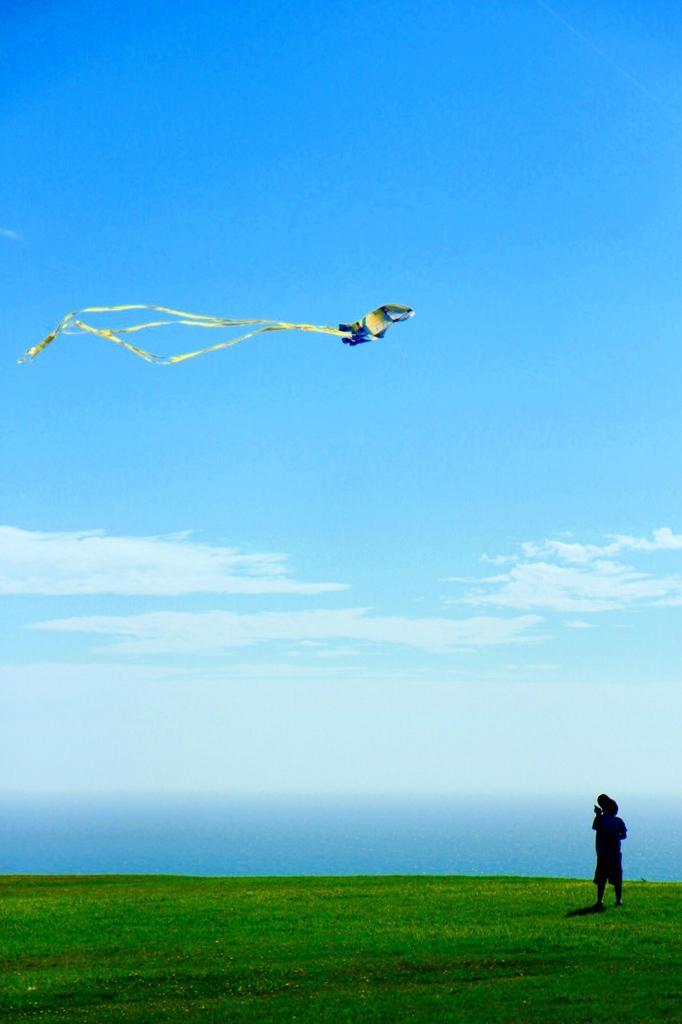Could you give a brief overview of what you see in this image? In this picture we can see one boy is standing on the grass and flying kite, we can see the sky. 